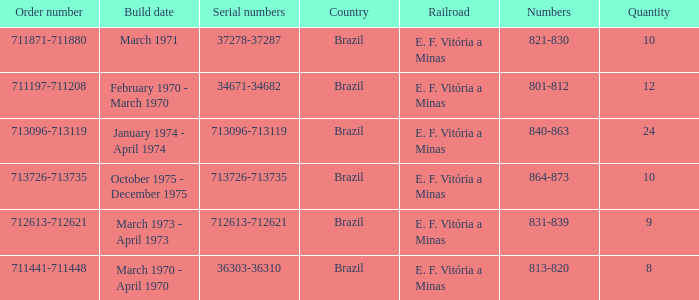The numbers 801-812 are in which country? Brazil. 